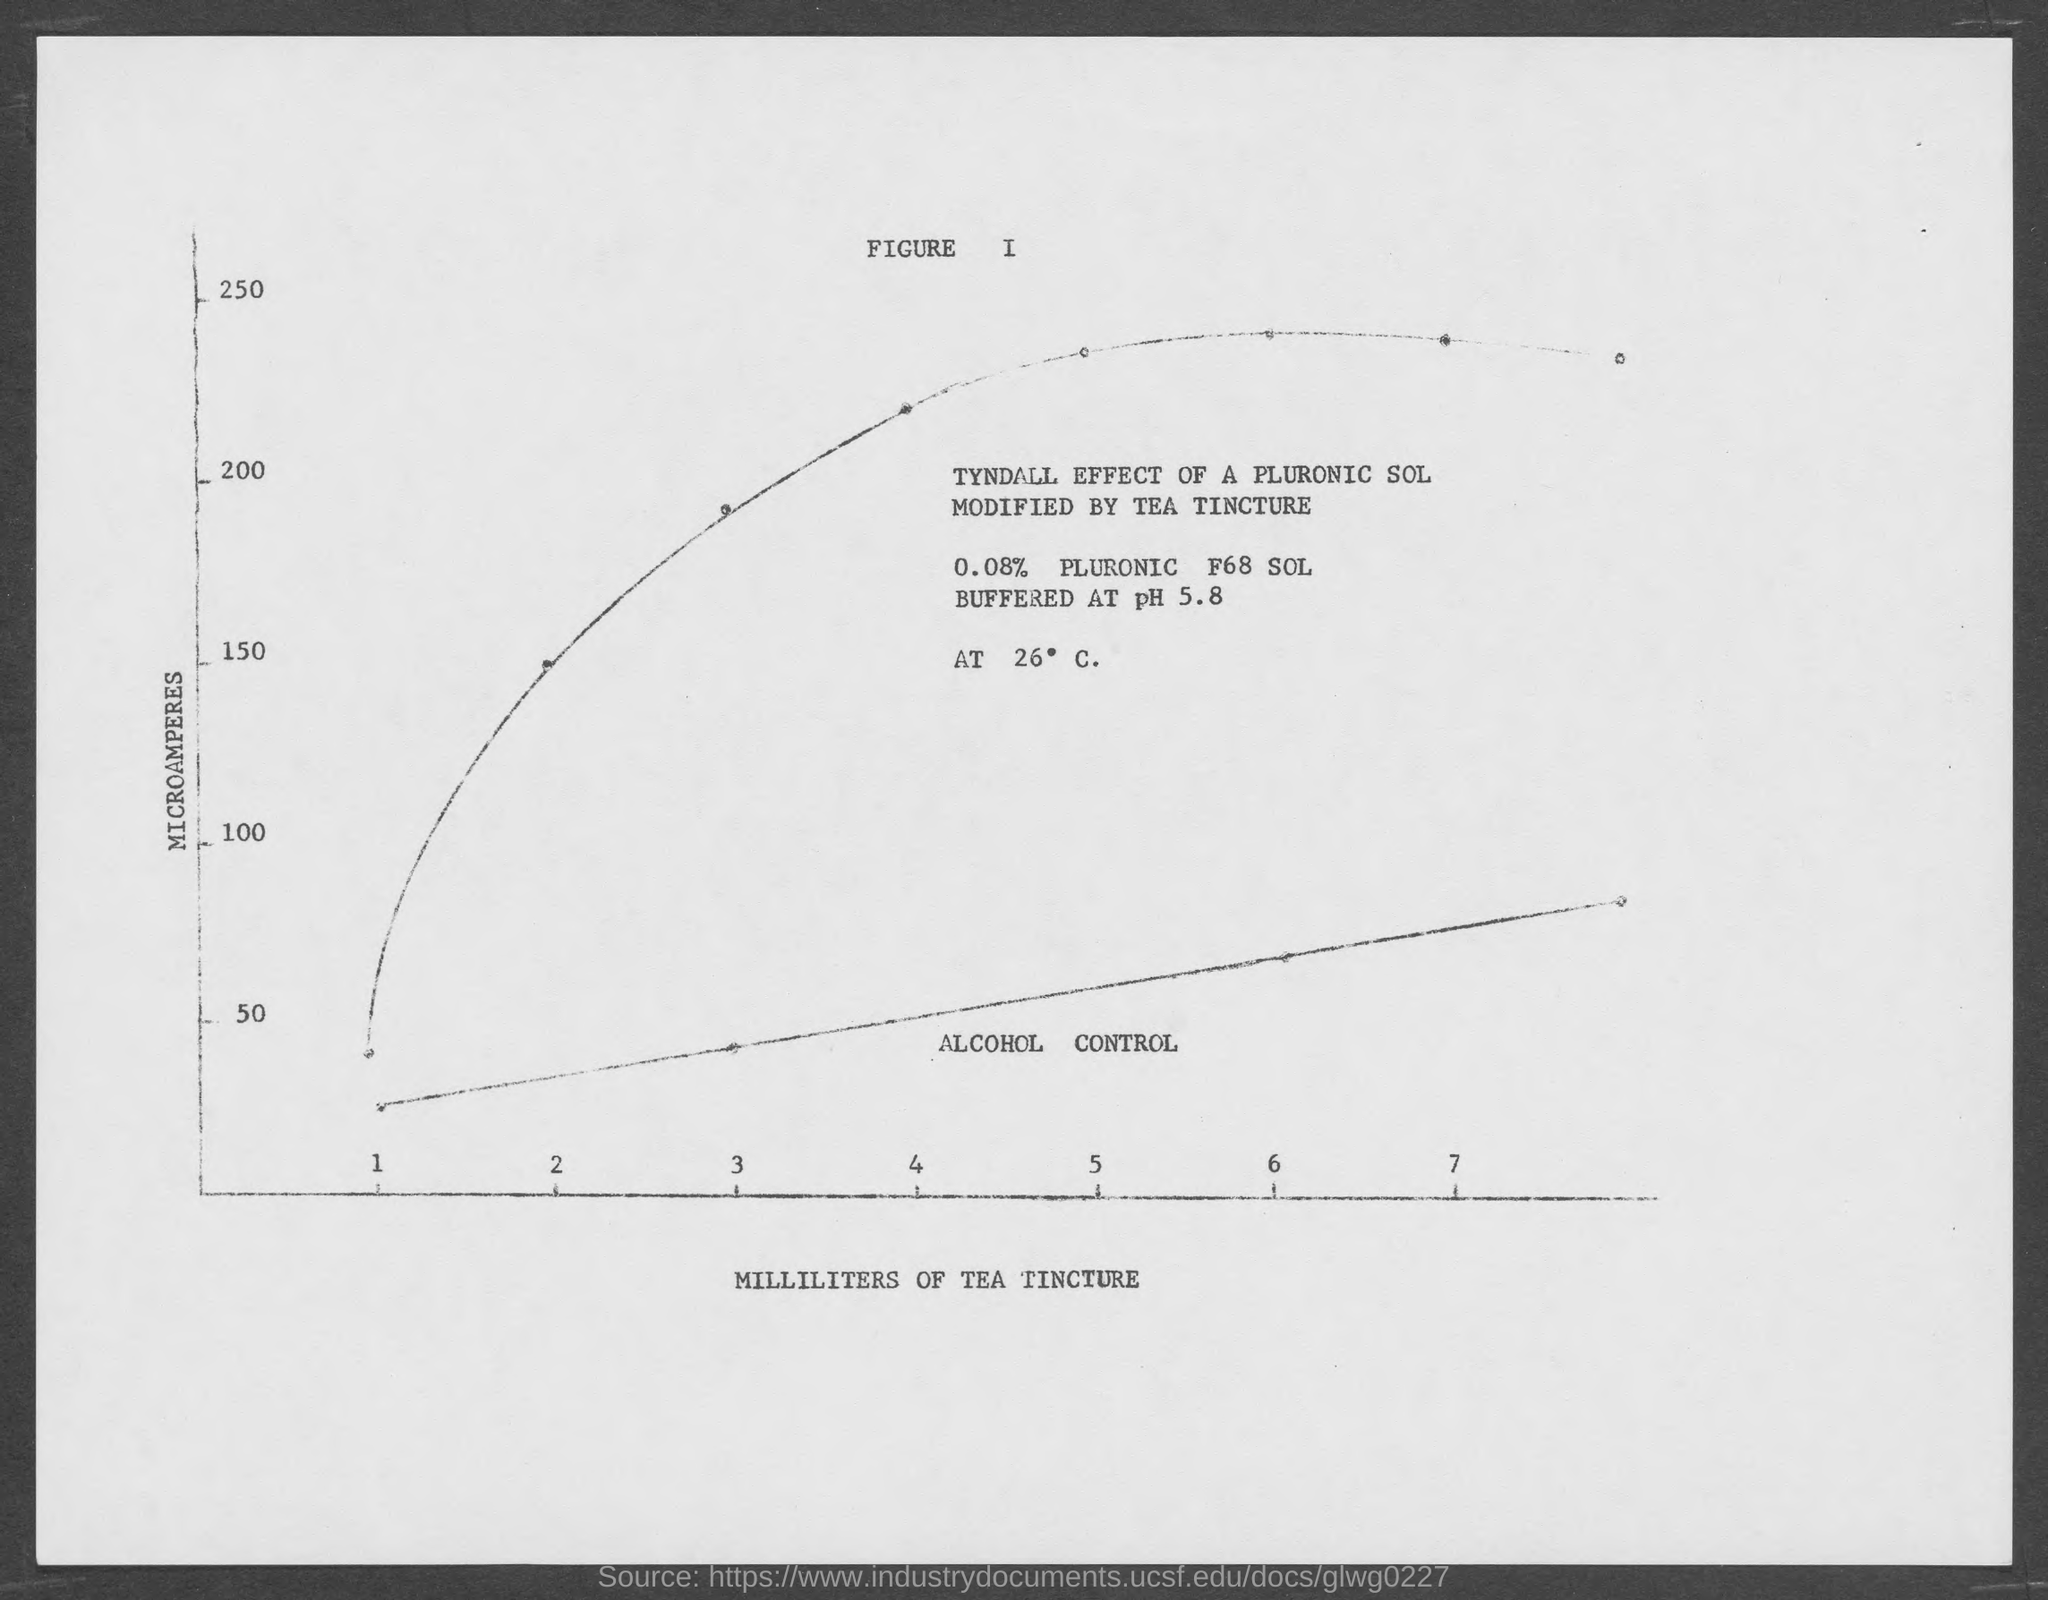Outline some significant characteristics in this image. The minimum value of "MICROAMPERES" taken in the Y-axis of the graph is 50. The maximum value of "MICROAMPERES" taken in the Y-axis of the graph is 250. The value "Milliliters of Tea Tincture" is plotted on the X-axis of the graph. The value represented on the vertical axis of the graph is microamperes. Approximately 0.08% of PLURONIC F68 SOL is buffered at a pH of 5.8. 